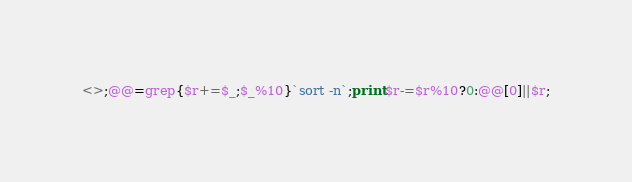Convert code to text. <code><loc_0><loc_0><loc_500><loc_500><_Perl_><>;@@=grep{$r+=$_;$_%10}`sort -n`;print$r-=$r%10?0:@@[0]||$r;</code> 